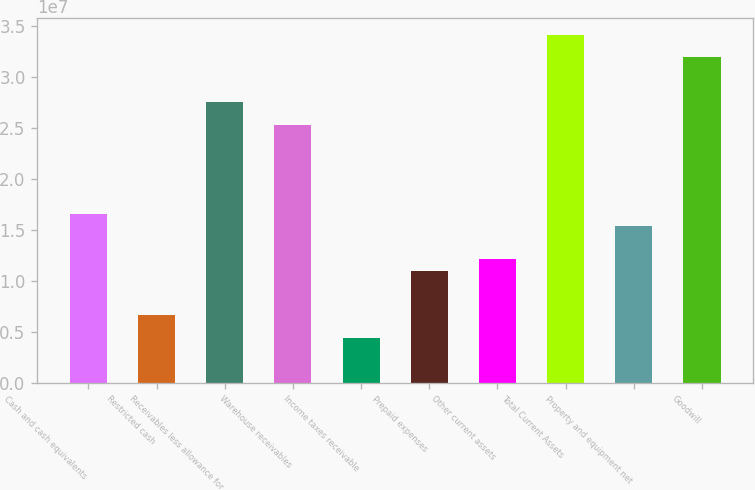<chart> <loc_0><loc_0><loc_500><loc_500><bar_chart><fcel>Cash and cash equivalents<fcel>Restricted cash<fcel>Receivables less allowance for<fcel>Warehouse receivables<fcel>Income taxes receivable<fcel>Prepaid expenses<fcel>Other current assets<fcel>Total Current Assets<fcel>Property and equipment net<fcel>Goodwill<nl><fcel>1.65269e+07<fcel>6.61077e+06<fcel>2.75448e+07<fcel>2.53412e+07<fcel>4.40719e+06<fcel>1.10179e+07<fcel>1.21197e+07<fcel>3.41556e+07<fcel>1.54251e+07<fcel>3.1952e+07<nl></chart> 